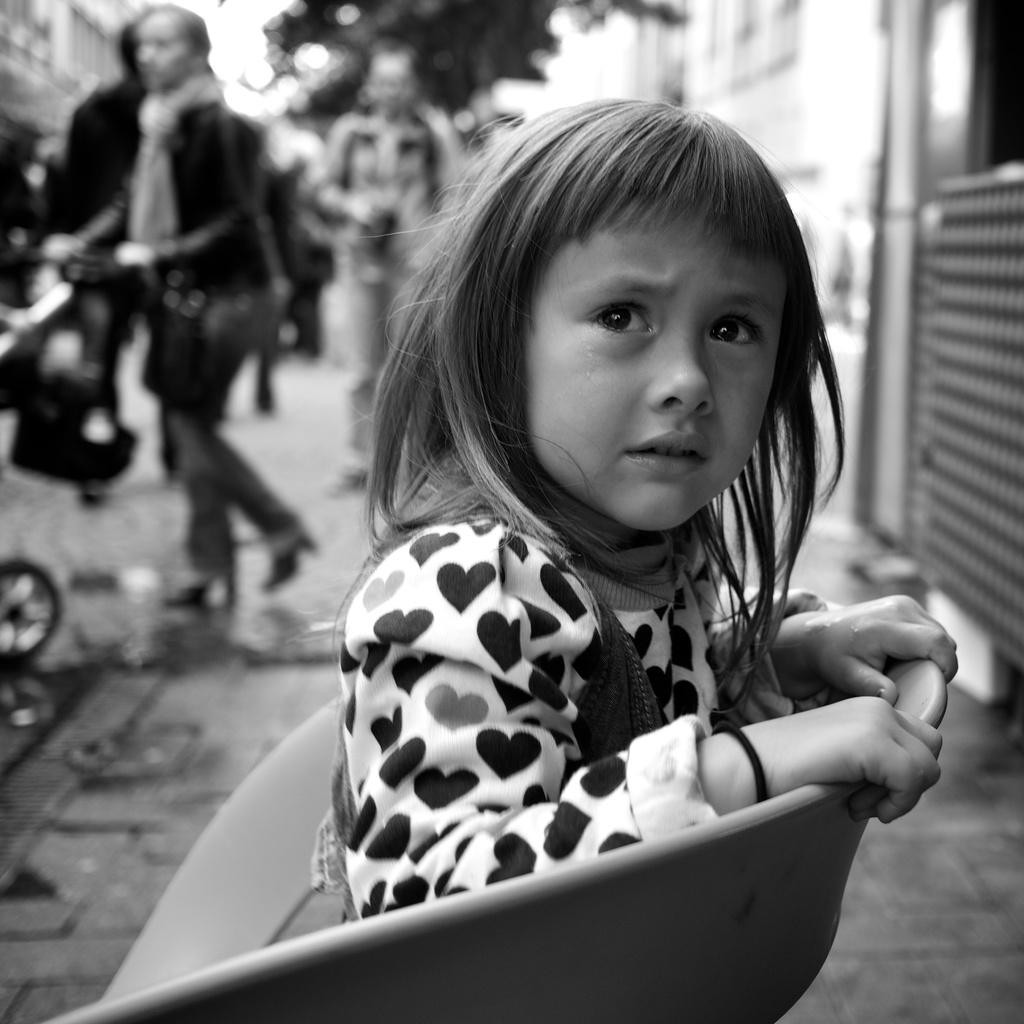What is the color scheme of the image? The image is black and white. What is the girl in the image doing? The girl is sitting on a chair and crying. Are there any other people in the image? Yes, there are people standing behind the girl. How clear are the images of the people behind the girl? The images of the people behind the girl are blurry. What type of glue is the girl using to stick the number on the orange in the image? There is no glue, number, or orange present in the image. 